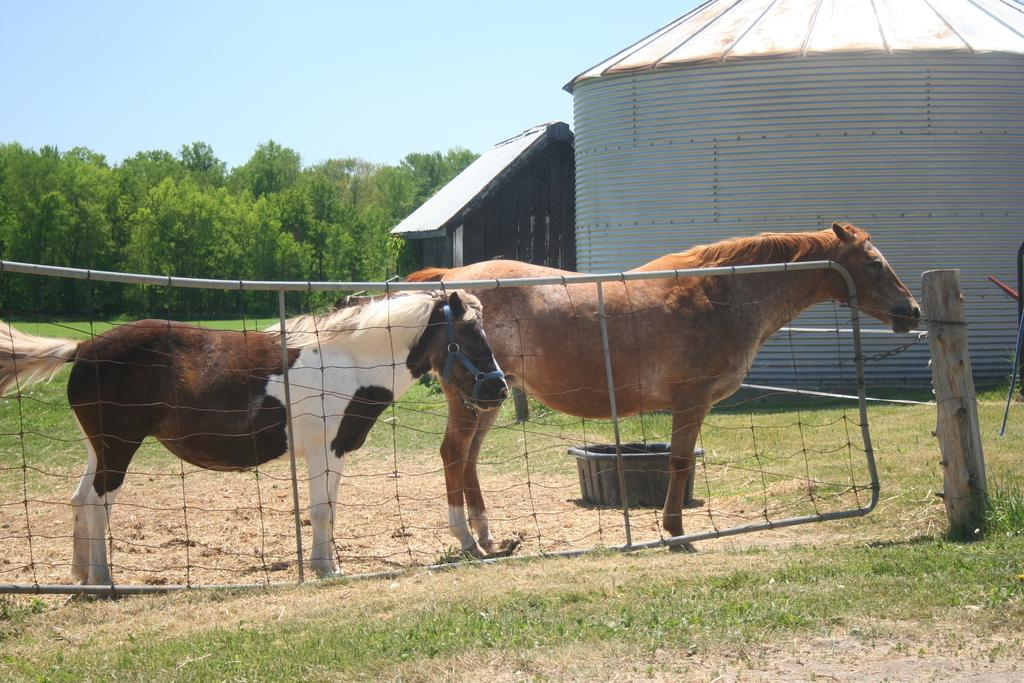What animals are in the center of the image? There are horses in the center of the image. What is separating the horses from the rest of the image? There is a fence in the image. What structures can be seen in the background of the image? There are sheds in the background of the image. What type of vegetation is visible in the background of the image? There are trees in the background of the image. What part of the natural environment is visible in the image? The sky is visible in the background of the image, and there is grass at the bottom of the image. What type of cork can be seen in the image? There is no cork present in the image. Can you describe the behavior of the woman in the image? There is no woman present in the image, so it is not possible to describe her behavior. 